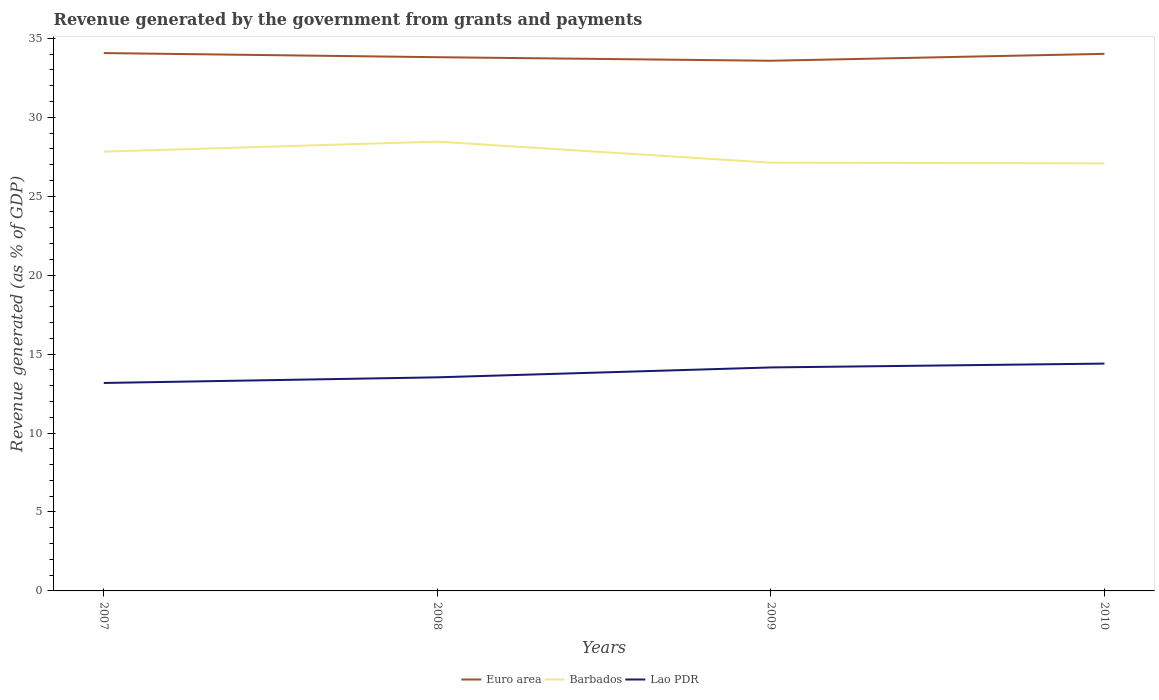Does the line corresponding to Euro area intersect with the line corresponding to Barbados?
Offer a very short reply. No. Across all years, what is the maximum revenue generated by the government in Barbados?
Your answer should be very brief. 27.08. In which year was the revenue generated by the government in Euro area maximum?
Your answer should be very brief. 2009. What is the total revenue generated by the government in Lao PDR in the graph?
Ensure brevity in your answer.  -1.23. What is the difference between the highest and the second highest revenue generated by the government in Euro area?
Offer a very short reply. 0.49. How many years are there in the graph?
Your answer should be compact. 4. Does the graph contain grids?
Ensure brevity in your answer.  No. Where does the legend appear in the graph?
Your answer should be very brief. Bottom center. How many legend labels are there?
Your answer should be compact. 3. What is the title of the graph?
Offer a very short reply. Revenue generated by the government from grants and payments. What is the label or title of the Y-axis?
Your answer should be very brief. Revenue generated (as % of GDP). What is the Revenue generated (as % of GDP) of Euro area in 2007?
Provide a succinct answer. 34.06. What is the Revenue generated (as % of GDP) in Barbados in 2007?
Your answer should be compact. 27.82. What is the Revenue generated (as % of GDP) of Lao PDR in 2007?
Provide a short and direct response. 13.17. What is the Revenue generated (as % of GDP) in Euro area in 2008?
Your response must be concise. 33.8. What is the Revenue generated (as % of GDP) in Barbados in 2008?
Provide a succinct answer. 28.45. What is the Revenue generated (as % of GDP) of Lao PDR in 2008?
Make the answer very short. 13.53. What is the Revenue generated (as % of GDP) of Euro area in 2009?
Give a very brief answer. 33.58. What is the Revenue generated (as % of GDP) in Barbados in 2009?
Offer a terse response. 27.12. What is the Revenue generated (as % of GDP) of Lao PDR in 2009?
Your response must be concise. 14.15. What is the Revenue generated (as % of GDP) in Euro area in 2010?
Make the answer very short. 34.01. What is the Revenue generated (as % of GDP) of Barbados in 2010?
Offer a very short reply. 27.08. What is the Revenue generated (as % of GDP) of Lao PDR in 2010?
Ensure brevity in your answer.  14.4. Across all years, what is the maximum Revenue generated (as % of GDP) of Euro area?
Make the answer very short. 34.06. Across all years, what is the maximum Revenue generated (as % of GDP) in Barbados?
Offer a terse response. 28.45. Across all years, what is the maximum Revenue generated (as % of GDP) in Lao PDR?
Your answer should be very brief. 14.4. Across all years, what is the minimum Revenue generated (as % of GDP) of Euro area?
Provide a succinct answer. 33.58. Across all years, what is the minimum Revenue generated (as % of GDP) of Barbados?
Offer a very short reply. 27.08. Across all years, what is the minimum Revenue generated (as % of GDP) of Lao PDR?
Provide a short and direct response. 13.17. What is the total Revenue generated (as % of GDP) in Euro area in the graph?
Your answer should be very brief. 135.45. What is the total Revenue generated (as % of GDP) in Barbados in the graph?
Offer a very short reply. 110.47. What is the total Revenue generated (as % of GDP) in Lao PDR in the graph?
Give a very brief answer. 55.25. What is the difference between the Revenue generated (as % of GDP) in Euro area in 2007 and that in 2008?
Make the answer very short. 0.26. What is the difference between the Revenue generated (as % of GDP) in Barbados in 2007 and that in 2008?
Ensure brevity in your answer.  -0.63. What is the difference between the Revenue generated (as % of GDP) in Lao PDR in 2007 and that in 2008?
Your answer should be very brief. -0.36. What is the difference between the Revenue generated (as % of GDP) of Euro area in 2007 and that in 2009?
Provide a succinct answer. 0.49. What is the difference between the Revenue generated (as % of GDP) of Barbados in 2007 and that in 2009?
Offer a terse response. 0.7. What is the difference between the Revenue generated (as % of GDP) of Lao PDR in 2007 and that in 2009?
Make the answer very short. -0.98. What is the difference between the Revenue generated (as % of GDP) of Euro area in 2007 and that in 2010?
Ensure brevity in your answer.  0.05. What is the difference between the Revenue generated (as % of GDP) of Barbados in 2007 and that in 2010?
Offer a terse response. 0.74. What is the difference between the Revenue generated (as % of GDP) in Lao PDR in 2007 and that in 2010?
Provide a short and direct response. -1.23. What is the difference between the Revenue generated (as % of GDP) of Euro area in 2008 and that in 2009?
Your answer should be very brief. 0.22. What is the difference between the Revenue generated (as % of GDP) in Barbados in 2008 and that in 2009?
Give a very brief answer. 1.33. What is the difference between the Revenue generated (as % of GDP) in Lao PDR in 2008 and that in 2009?
Your response must be concise. -0.63. What is the difference between the Revenue generated (as % of GDP) in Euro area in 2008 and that in 2010?
Make the answer very short. -0.21. What is the difference between the Revenue generated (as % of GDP) of Barbados in 2008 and that in 2010?
Offer a very short reply. 1.38. What is the difference between the Revenue generated (as % of GDP) of Lao PDR in 2008 and that in 2010?
Give a very brief answer. -0.87. What is the difference between the Revenue generated (as % of GDP) in Euro area in 2009 and that in 2010?
Your answer should be compact. -0.44. What is the difference between the Revenue generated (as % of GDP) of Barbados in 2009 and that in 2010?
Keep it short and to the point. 0.04. What is the difference between the Revenue generated (as % of GDP) in Lao PDR in 2009 and that in 2010?
Your response must be concise. -0.24. What is the difference between the Revenue generated (as % of GDP) of Euro area in 2007 and the Revenue generated (as % of GDP) of Barbados in 2008?
Offer a terse response. 5.61. What is the difference between the Revenue generated (as % of GDP) in Euro area in 2007 and the Revenue generated (as % of GDP) in Lao PDR in 2008?
Your answer should be compact. 20.54. What is the difference between the Revenue generated (as % of GDP) in Barbados in 2007 and the Revenue generated (as % of GDP) in Lao PDR in 2008?
Offer a terse response. 14.29. What is the difference between the Revenue generated (as % of GDP) of Euro area in 2007 and the Revenue generated (as % of GDP) of Barbados in 2009?
Your answer should be compact. 6.94. What is the difference between the Revenue generated (as % of GDP) of Euro area in 2007 and the Revenue generated (as % of GDP) of Lao PDR in 2009?
Make the answer very short. 19.91. What is the difference between the Revenue generated (as % of GDP) of Barbados in 2007 and the Revenue generated (as % of GDP) of Lao PDR in 2009?
Your response must be concise. 13.67. What is the difference between the Revenue generated (as % of GDP) of Euro area in 2007 and the Revenue generated (as % of GDP) of Barbados in 2010?
Give a very brief answer. 6.98. What is the difference between the Revenue generated (as % of GDP) in Euro area in 2007 and the Revenue generated (as % of GDP) in Lao PDR in 2010?
Your answer should be very brief. 19.67. What is the difference between the Revenue generated (as % of GDP) in Barbados in 2007 and the Revenue generated (as % of GDP) in Lao PDR in 2010?
Offer a terse response. 13.42. What is the difference between the Revenue generated (as % of GDP) in Euro area in 2008 and the Revenue generated (as % of GDP) in Barbados in 2009?
Make the answer very short. 6.68. What is the difference between the Revenue generated (as % of GDP) of Euro area in 2008 and the Revenue generated (as % of GDP) of Lao PDR in 2009?
Offer a very short reply. 19.65. What is the difference between the Revenue generated (as % of GDP) of Barbados in 2008 and the Revenue generated (as % of GDP) of Lao PDR in 2009?
Offer a terse response. 14.3. What is the difference between the Revenue generated (as % of GDP) in Euro area in 2008 and the Revenue generated (as % of GDP) in Barbados in 2010?
Your answer should be compact. 6.72. What is the difference between the Revenue generated (as % of GDP) in Euro area in 2008 and the Revenue generated (as % of GDP) in Lao PDR in 2010?
Your answer should be compact. 19.4. What is the difference between the Revenue generated (as % of GDP) in Barbados in 2008 and the Revenue generated (as % of GDP) in Lao PDR in 2010?
Provide a short and direct response. 14.06. What is the difference between the Revenue generated (as % of GDP) in Euro area in 2009 and the Revenue generated (as % of GDP) in Barbados in 2010?
Offer a terse response. 6.5. What is the difference between the Revenue generated (as % of GDP) in Euro area in 2009 and the Revenue generated (as % of GDP) in Lao PDR in 2010?
Offer a very short reply. 19.18. What is the difference between the Revenue generated (as % of GDP) of Barbados in 2009 and the Revenue generated (as % of GDP) of Lao PDR in 2010?
Provide a succinct answer. 12.72. What is the average Revenue generated (as % of GDP) of Euro area per year?
Your response must be concise. 33.86. What is the average Revenue generated (as % of GDP) in Barbados per year?
Keep it short and to the point. 27.62. What is the average Revenue generated (as % of GDP) of Lao PDR per year?
Keep it short and to the point. 13.81. In the year 2007, what is the difference between the Revenue generated (as % of GDP) in Euro area and Revenue generated (as % of GDP) in Barbados?
Ensure brevity in your answer.  6.24. In the year 2007, what is the difference between the Revenue generated (as % of GDP) of Euro area and Revenue generated (as % of GDP) of Lao PDR?
Offer a very short reply. 20.89. In the year 2007, what is the difference between the Revenue generated (as % of GDP) of Barbados and Revenue generated (as % of GDP) of Lao PDR?
Give a very brief answer. 14.65. In the year 2008, what is the difference between the Revenue generated (as % of GDP) in Euro area and Revenue generated (as % of GDP) in Barbados?
Give a very brief answer. 5.35. In the year 2008, what is the difference between the Revenue generated (as % of GDP) in Euro area and Revenue generated (as % of GDP) in Lao PDR?
Provide a short and direct response. 20.27. In the year 2008, what is the difference between the Revenue generated (as % of GDP) of Barbados and Revenue generated (as % of GDP) of Lao PDR?
Offer a very short reply. 14.93. In the year 2009, what is the difference between the Revenue generated (as % of GDP) in Euro area and Revenue generated (as % of GDP) in Barbados?
Provide a short and direct response. 6.46. In the year 2009, what is the difference between the Revenue generated (as % of GDP) of Euro area and Revenue generated (as % of GDP) of Lao PDR?
Your response must be concise. 19.42. In the year 2009, what is the difference between the Revenue generated (as % of GDP) of Barbados and Revenue generated (as % of GDP) of Lao PDR?
Your answer should be very brief. 12.97. In the year 2010, what is the difference between the Revenue generated (as % of GDP) of Euro area and Revenue generated (as % of GDP) of Barbados?
Your answer should be very brief. 6.93. In the year 2010, what is the difference between the Revenue generated (as % of GDP) of Euro area and Revenue generated (as % of GDP) of Lao PDR?
Provide a succinct answer. 19.62. In the year 2010, what is the difference between the Revenue generated (as % of GDP) of Barbados and Revenue generated (as % of GDP) of Lao PDR?
Offer a terse response. 12.68. What is the ratio of the Revenue generated (as % of GDP) of Euro area in 2007 to that in 2008?
Your response must be concise. 1.01. What is the ratio of the Revenue generated (as % of GDP) of Barbados in 2007 to that in 2008?
Your answer should be very brief. 0.98. What is the ratio of the Revenue generated (as % of GDP) in Lao PDR in 2007 to that in 2008?
Your answer should be compact. 0.97. What is the ratio of the Revenue generated (as % of GDP) of Euro area in 2007 to that in 2009?
Your answer should be very brief. 1.01. What is the ratio of the Revenue generated (as % of GDP) of Barbados in 2007 to that in 2009?
Your answer should be very brief. 1.03. What is the ratio of the Revenue generated (as % of GDP) of Lao PDR in 2007 to that in 2009?
Give a very brief answer. 0.93. What is the ratio of the Revenue generated (as % of GDP) of Euro area in 2007 to that in 2010?
Make the answer very short. 1. What is the ratio of the Revenue generated (as % of GDP) of Barbados in 2007 to that in 2010?
Provide a succinct answer. 1.03. What is the ratio of the Revenue generated (as % of GDP) of Lao PDR in 2007 to that in 2010?
Your response must be concise. 0.91. What is the ratio of the Revenue generated (as % of GDP) in Barbados in 2008 to that in 2009?
Provide a short and direct response. 1.05. What is the ratio of the Revenue generated (as % of GDP) of Lao PDR in 2008 to that in 2009?
Offer a very short reply. 0.96. What is the ratio of the Revenue generated (as % of GDP) of Euro area in 2008 to that in 2010?
Your response must be concise. 0.99. What is the ratio of the Revenue generated (as % of GDP) of Barbados in 2008 to that in 2010?
Offer a terse response. 1.05. What is the ratio of the Revenue generated (as % of GDP) in Lao PDR in 2008 to that in 2010?
Make the answer very short. 0.94. What is the ratio of the Revenue generated (as % of GDP) in Euro area in 2009 to that in 2010?
Make the answer very short. 0.99. What is the ratio of the Revenue generated (as % of GDP) of Barbados in 2009 to that in 2010?
Offer a very short reply. 1. What is the ratio of the Revenue generated (as % of GDP) in Lao PDR in 2009 to that in 2010?
Your response must be concise. 0.98. What is the difference between the highest and the second highest Revenue generated (as % of GDP) of Euro area?
Your response must be concise. 0.05. What is the difference between the highest and the second highest Revenue generated (as % of GDP) of Barbados?
Ensure brevity in your answer.  0.63. What is the difference between the highest and the second highest Revenue generated (as % of GDP) in Lao PDR?
Provide a succinct answer. 0.24. What is the difference between the highest and the lowest Revenue generated (as % of GDP) of Euro area?
Provide a succinct answer. 0.49. What is the difference between the highest and the lowest Revenue generated (as % of GDP) in Barbados?
Give a very brief answer. 1.38. What is the difference between the highest and the lowest Revenue generated (as % of GDP) in Lao PDR?
Your response must be concise. 1.23. 